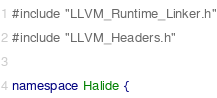<code> <loc_0><loc_0><loc_500><loc_500><_C++_>#include "LLVM_Runtime_Linker.h"
#include "LLVM_Headers.h"

namespace Halide {
</code> 